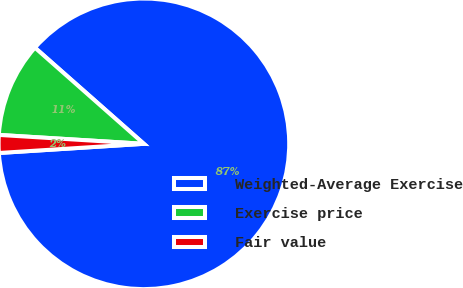Convert chart to OTSL. <chart><loc_0><loc_0><loc_500><loc_500><pie_chart><fcel>Weighted-Average Exercise<fcel>Exercise price<fcel>Fair value<nl><fcel>87.48%<fcel>10.53%<fcel>1.98%<nl></chart> 